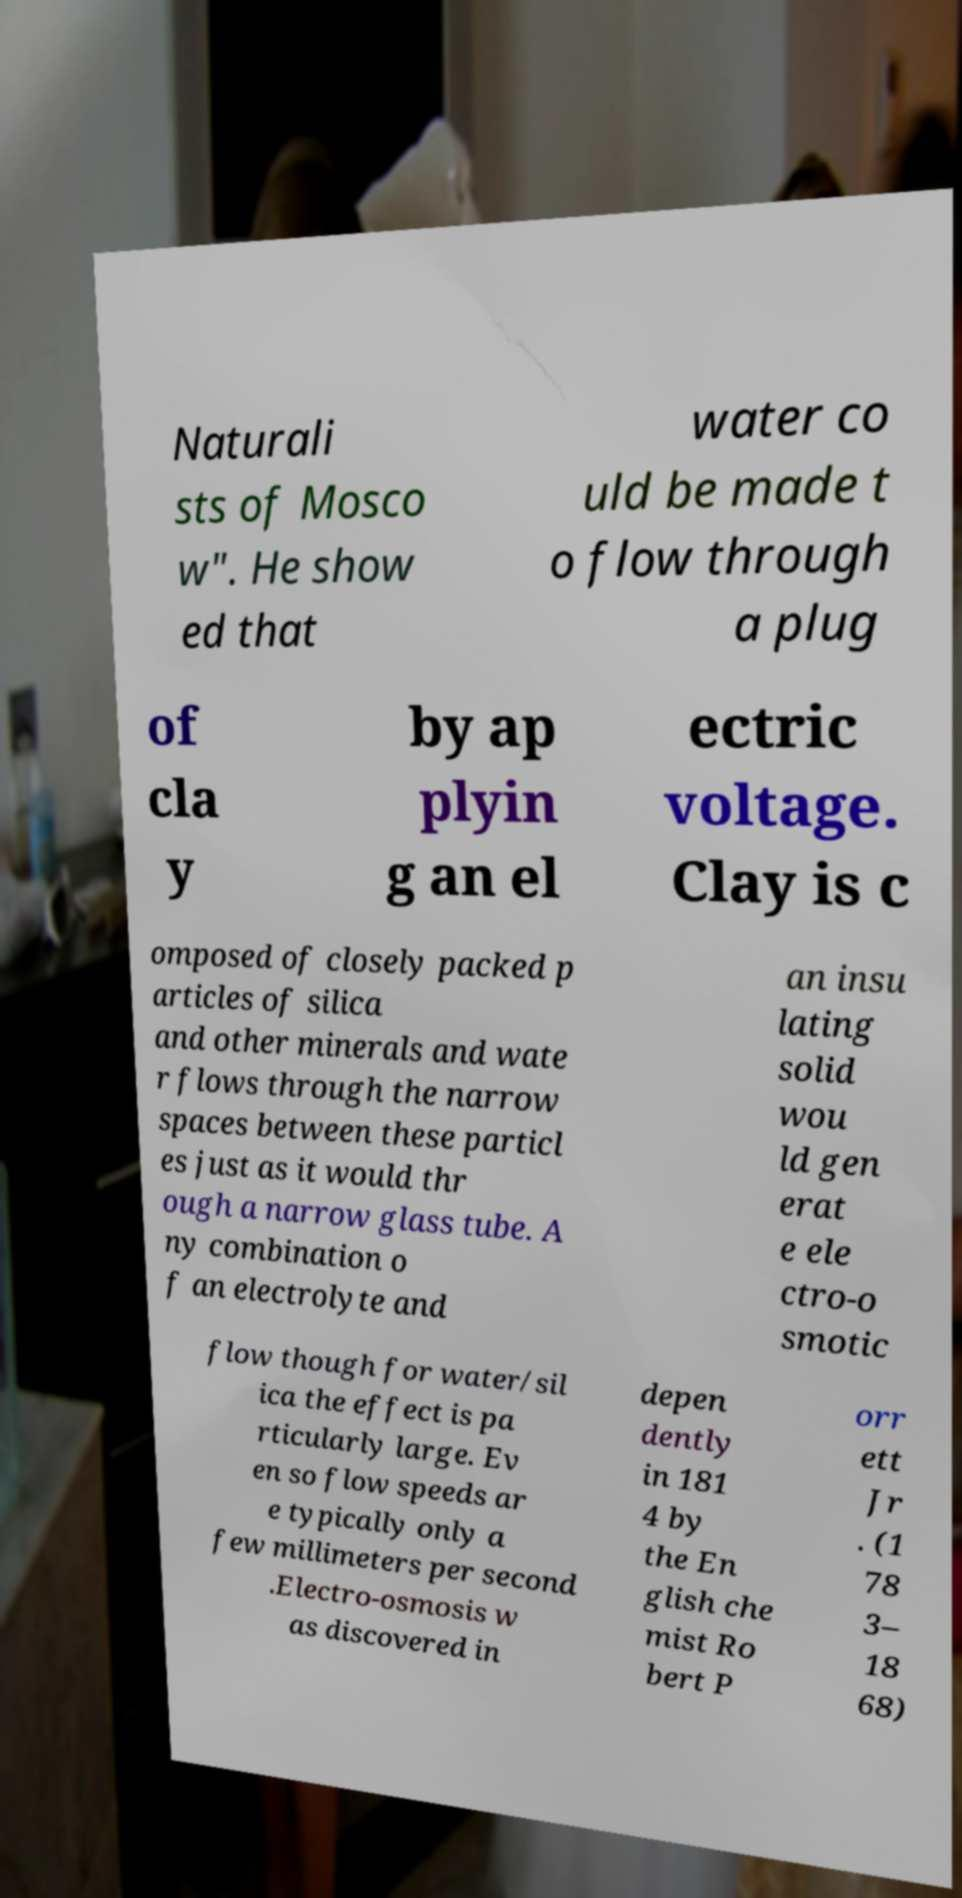Can you read and provide the text displayed in the image?This photo seems to have some interesting text. Can you extract and type it out for me? Naturali sts of Mosco w". He show ed that water co uld be made t o flow through a plug of cla y by ap plyin g an el ectric voltage. Clay is c omposed of closely packed p articles of silica and other minerals and wate r flows through the narrow spaces between these particl es just as it would thr ough a narrow glass tube. A ny combination o f an electrolyte and an insu lating solid wou ld gen erat e ele ctro-o smotic flow though for water/sil ica the effect is pa rticularly large. Ev en so flow speeds ar e typically only a few millimeters per second .Electro-osmosis w as discovered in depen dently in 181 4 by the En glish che mist Ro bert P orr ett Jr . (1 78 3– 18 68) 